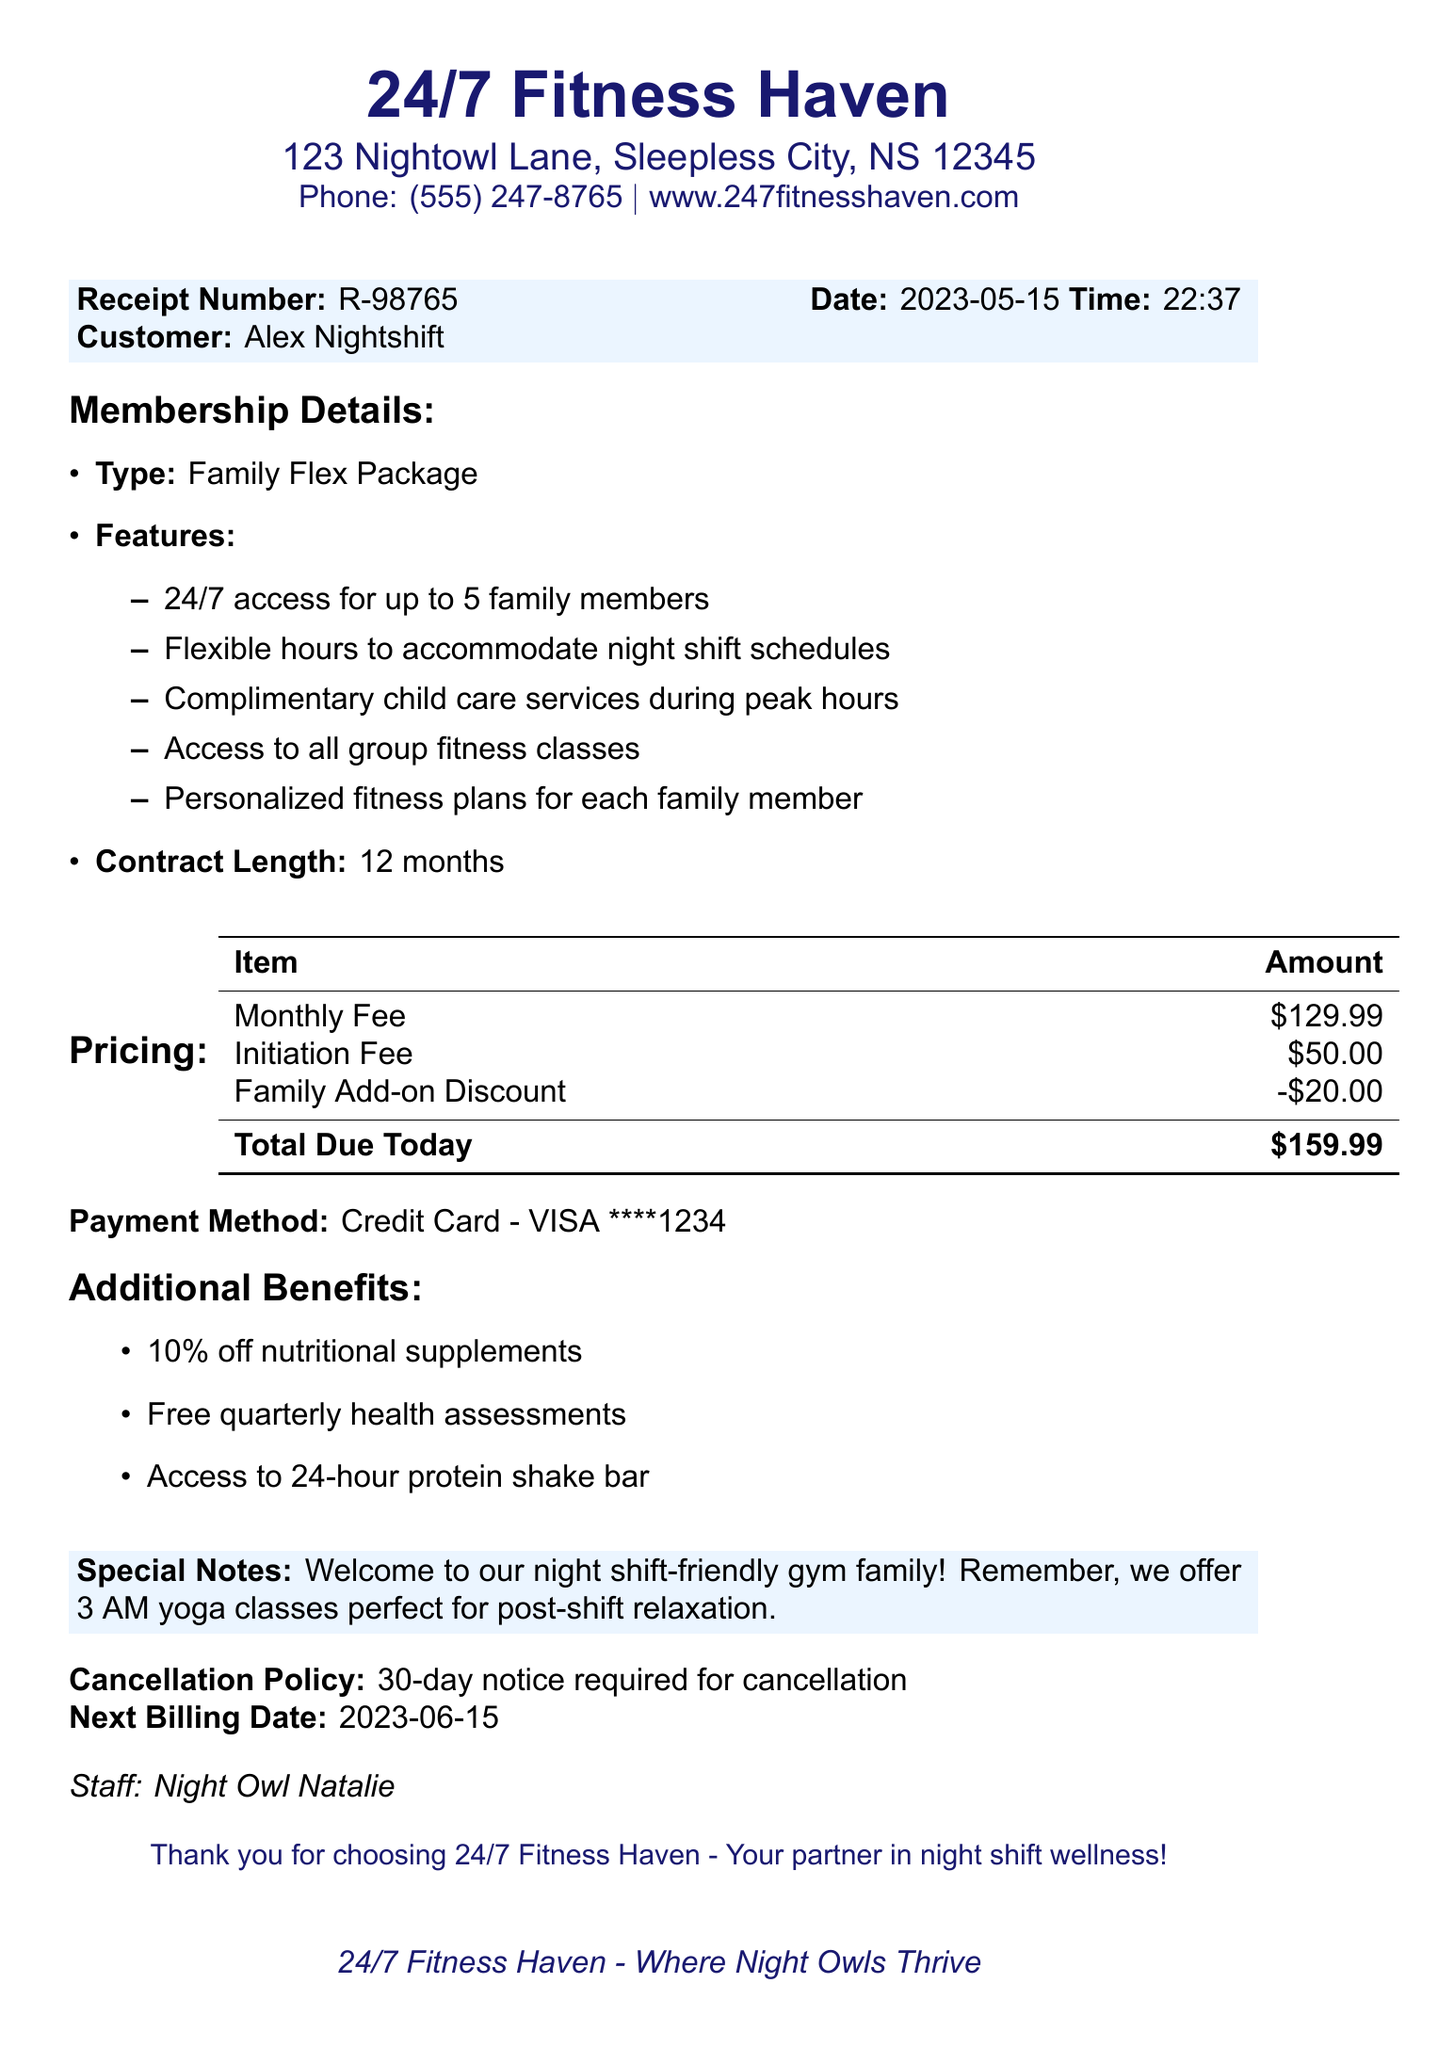What is the gym's name? The gym's name is listed at the top of the document.
Answer: 24/7 Fitness Haven What is the address of the gym? The address is provided right below the gym's name.
Answer: 123 Nightowl Lane, Sleepless City, NS 12345 What is the total due today? The total due today is summarized in the pricing section of the receipt.
Answer: $159.99 Who is the customer named on the receipt? The customer's name is stated in the customer section of the document.
Answer: Alex Nightshift What is the membership type purchased? The membership type is mentioned in the membership details section.
Answer: Family Flex Package How long is the contract length for the membership? The contract length is specified in the membership details section.
Answer: 12 months How much is the initiation fee? The initiation fee is listed in the pricing section of the receipt.
Answer: $50.00 What are the complimentary services offered during peak hours? Complimentary services are mentioned in the membership details section.
Answer: Child care services What is the cancellation policy? The cancellation policy is specified towards the end of the document.
Answer: 30-day notice required for cancellation When is the next billing date? The next billing date is provided towards the end of the receipt.
Answer: 2023-06-15 